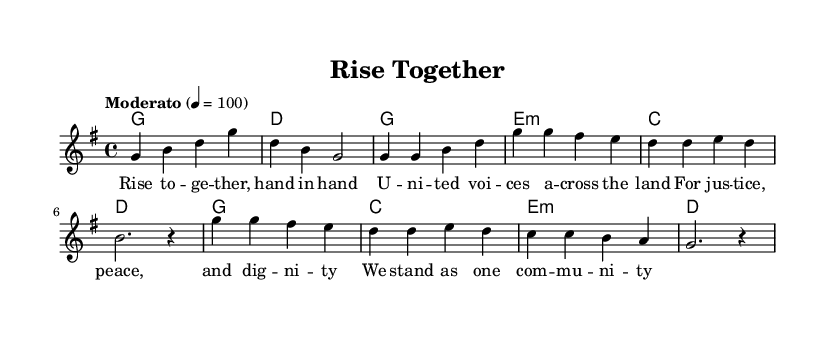What is the key signature of this music? The key signature is G major, indicated by one sharp (F#) at the beginning. This can be determined by looking for the number of sharps or flats in the key signature displayed on the staff.
Answer: G major What is the time signature of this piece? The time signature is 4/4, which can be identified in the beginning of the piece where the notation shows two numbers stacked, 4 above 4. This indicates there are four beats in each measure and a quarter note gets one beat.
Answer: 4/4 What is the tempo marking for this song? The tempo marking is "Moderato," suggesting a moderate pace for the piece; it is followed by a specific beat value (4 = 100) that indicates the speed of the music. This can be seen right at the start in the tempo indication area.
Answer: Moderato How many measures are in the chorus? The chorus contains 4 measures, which can be counted by examining the notation specifically in the chorus section where each group of notes represents one measure until the end of that section.
Answer: 4 What is the final chord of the chorus? The final chord of the chorus is D major, which is indicated by the chord symbols placed above the melody in the score. In the last measure of the chorus, the D chord is specifically notated, confirming it as the final chord.
Answer: D What do the lyrics repeated in the chorus emphasize? The lyrics repeated in the chorus emphasize unity and social justice, as indicated in the text that speaks of standing together as one community for justice, peace, and dignity. This reflects a common theme found in folk anthems addressing sociopolitical issues.
Answer: Unity What is the rhyme scheme of the verse? The rhyme scheme of the verse is AABB, where each pair of lines ends with words that rhyme, creating a simple and memorable structure typical for folk music to enhance singability and engagement. The instructions in the lyrics reflect this pattern.
Answer: AABB 